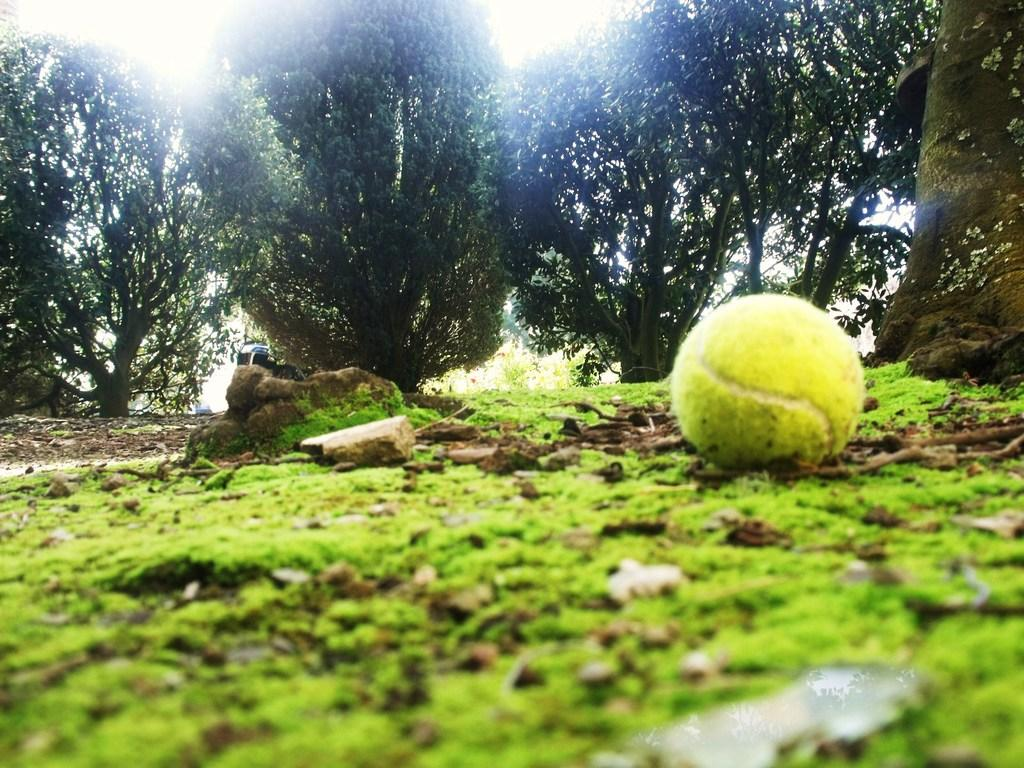Where was the picture taken? The picture was clicked outside. What object can be seen on the right side of the image? There is a ball placed on the ground on the right side. What type of vegetation is visible in the image? There is green grass visible in the image. What other natural elements can be seen in the image? There are rocks in the image. What is visible in the background of the image? The sky and trees are visible in the background. Can you tell me how many goats are present in the image? There are no goats present in the image. What type of magic is being performed with the ball in the image? There is no magic or any indication of a magical event in the image; it simply shows a ball placed on the ground. 